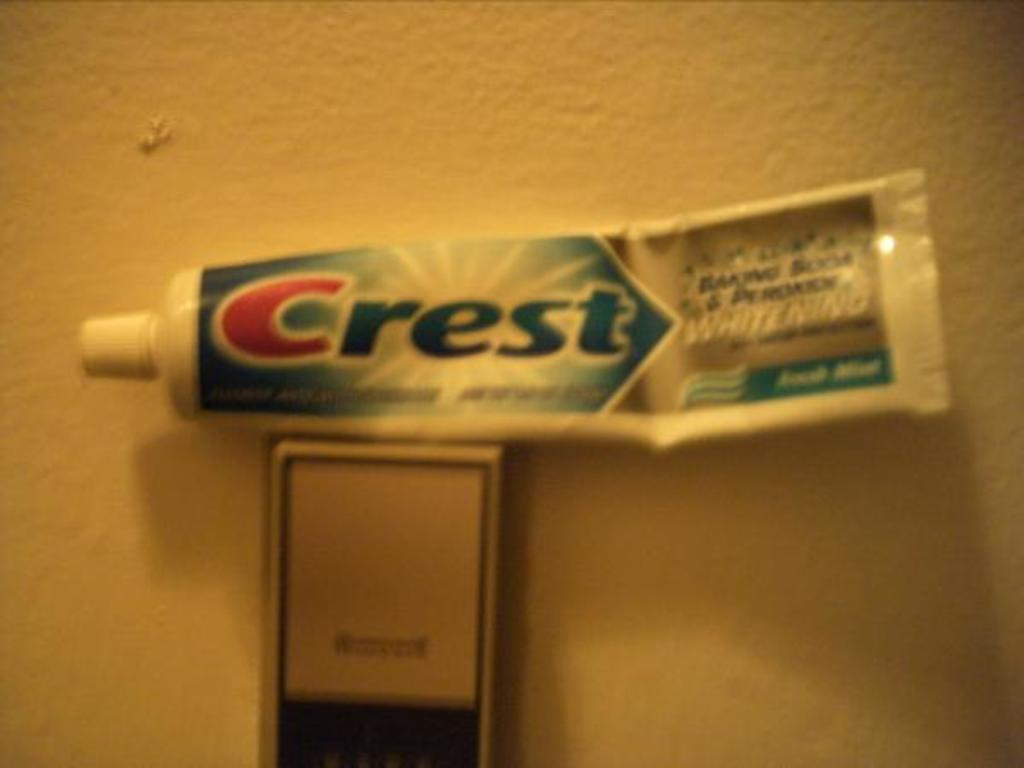<image>
Render a clear and concise summary of the photo. some toothpaste that has the brand Crest on it 